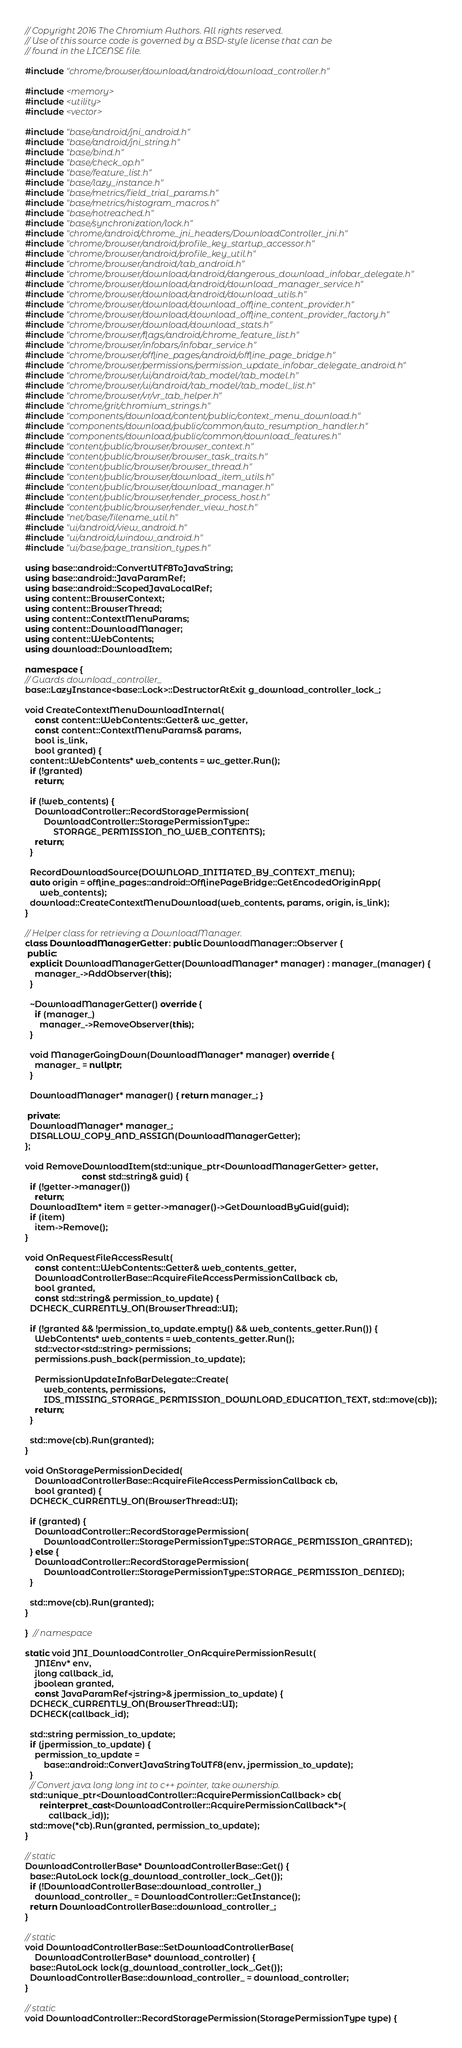<code> <loc_0><loc_0><loc_500><loc_500><_C++_>// Copyright 2016 The Chromium Authors. All rights reserved.
// Use of this source code is governed by a BSD-style license that can be
// found in the LICENSE file.

#include "chrome/browser/download/android/download_controller.h"

#include <memory>
#include <utility>
#include <vector>

#include "base/android/jni_android.h"
#include "base/android/jni_string.h"
#include "base/bind.h"
#include "base/check_op.h"
#include "base/feature_list.h"
#include "base/lazy_instance.h"
#include "base/metrics/field_trial_params.h"
#include "base/metrics/histogram_macros.h"
#include "base/notreached.h"
#include "base/synchronization/lock.h"
#include "chrome/android/chrome_jni_headers/DownloadController_jni.h"
#include "chrome/browser/android/profile_key_startup_accessor.h"
#include "chrome/browser/android/profile_key_util.h"
#include "chrome/browser/android/tab_android.h"
#include "chrome/browser/download/android/dangerous_download_infobar_delegate.h"
#include "chrome/browser/download/android/download_manager_service.h"
#include "chrome/browser/download/android/download_utils.h"
#include "chrome/browser/download/download_offline_content_provider.h"
#include "chrome/browser/download/download_offline_content_provider_factory.h"
#include "chrome/browser/download/download_stats.h"
#include "chrome/browser/flags/android/chrome_feature_list.h"
#include "chrome/browser/infobars/infobar_service.h"
#include "chrome/browser/offline_pages/android/offline_page_bridge.h"
#include "chrome/browser/permissions/permission_update_infobar_delegate_android.h"
#include "chrome/browser/ui/android/tab_model/tab_model.h"
#include "chrome/browser/ui/android/tab_model/tab_model_list.h"
#include "chrome/browser/vr/vr_tab_helper.h"
#include "chrome/grit/chromium_strings.h"
#include "components/download/content/public/context_menu_download.h"
#include "components/download/public/common/auto_resumption_handler.h"
#include "components/download/public/common/download_features.h"
#include "content/public/browser/browser_context.h"
#include "content/public/browser/browser_task_traits.h"
#include "content/public/browser/browser_thread.h"
#include "content/public/browser/download_item_utils.h"
#include "content/public/browser/download_manager.h"
#include "content/public/browser/render_process_host.h"
#include "content/public/browser/render_view_host.h"
#include "net/base/filename_util.h"
#include "ui/android/view_android.h"
#include "ui/android/window_android.h"
#include "ui/base/page_transition_types.h"

using base::android::ConvertUTF8ToJavaString;
using base::android::JavaParamRef;
using base::android::ScopedJavaLocalRef;
using content::BrowserContext;
using content::BrowserThread;
using content::ContextMenuParams;
using content::DownloadManager;
using content::WebContents;
using download::DownloadItem;

namespace {
// Guards download_controller_
base::LazyInstance<base::Lock>::DestructorAtExit g_download_controller_lock_;

void CreateContextMenuDownloadInternal(
    const content::WebContents::Getter& wc_getter,
    const content::ContextMenuParams& params,
    bool is_link,
    bool granted) {
  content::WebContents* web_contents = wc_getter.Run();
  if (!granted)
    return;

  if (!web_contents) {
    DownloadController::RecordStoragePermission(
        DownloadController::StoragePermissionType::
            STORAGE_PERMISSION_NO_WEB_CONTENTS);
    return;
  }

  RecordDownloadSource(DOWNLOAD_INITIATED_BY_CONTEXT_MENU);
  auto origin = offline_pages::android::OfflinePageBridge::GetEncodedOriginApp(
      web_contents);
  download::CreateContextMenuDownload(web_contents, params, origin, is_link);
}

// Helper class for retrieving a DownloadManager.
class DownloadManagerGetter : public DownloadManager::Observer {
 public:
  explicit DownloadManagerGetter(DownloadManager* manager) : manager_(manager) {
    manager_->AddObserver(this);
  }

  ~DownloadManagerGetter() override {
    if (manager_)
      manager_->RemoveObserver(this);
  }

  void ManagerGoingDown(DownloadManager* manager) override {
    manager_ = nullptr;
  }

  DownloadManager* manager() { return manager_; }

 private:
  DownloadManager* manager_;
  DISALLOW_COPY_AND_ASSIGN(DownloadManagerGetter);
};

void RemoveDownloadItem(std::unique_ptr<DownloadManagerGetter> getter,
                        const std::string& guid) {
  if (!getter->manager())
    return;
  DownloadItem* item = getter->manager()->GetDownloadByGuid(guid);
  if (item)
    item->Remove();
}

void OnRequestFileAccessResult(
    const content::WebContents::Getter& web_contents_getter,
    DownloadControllerBase::AcquireFileAccessPermissionCallback cb,
    bool granted,
    const std::string& permission_to_update) {
  DCHECK_CURRENTLY_ON(BrowserThread::UI);

  if (!granted && !permission_to_update.empty() && web_contents_getter.Run()) {
    WebContents* web_contents = web_contents_getter.Run();
    std::vector<std::string> permissions;
    permissions.push_back(permission_to_update);

    PermissionUpdateInfoBarDelegate::Create(
        web_contents, permissions,
        IDS_MISSING_STORAGE_PERMISSION_DOWNLOAD_EDUCATION_TEXT, std::move(cb));
    return;
  }

  std::move(cb).Run(granted);
}

void OnStoragePermissionDecided(
    DownloadControllerBase::AcquireFileAccessPermissionCallback cb,
    bool granted) {
  DCHECK_CURRENTLY_ON(BrowserThread::UI);

  if (granted) {
    DownloadController::RecordStoragePermission(
        DownloadController::StoragePermissionType::STORAGE_PERMISSION_GRANTED);
  } else {
    DownloadController::RecordStoragePermission(
        DownloadController::StoragePermissionType::STORAGE_PERMISSION_DENIED);
  }

  std::move(cb).Run(granted);
}

}  // namespace

static void JNI_DownloadController_OnAcquirePermissionResult(
    JNIEnv* env,
    jlong callback_id,
    jboolean granted,
    const JavaParamRef<jstring>& jpermission_to_update) {
  DCHECK_CURRENTLY_ON(BrowserThread::UI);
  DCHECK(callback_id);

  std::string permission_to_update;
  if (jpermission_to_update) {
    permission_to_update =
        base::android::ConvertJavaStringToUTF8(env, jpermission_to_update);
  }
  // Convert java long long int to c++ pointer, take ownership.
  std::unique_ptr<DownloadController::AcquirePermissionCallback> cb(
      reinterpret_cast<DownloadController::AcquirePermissionCallback*>(
          callback_id));
  std::move(*cb).Run(granted, permission_to_update);
}

// static
DownloadControllerBase* DownloadControllerBase::Get() {
  base::AutoLock lock(g_download_controller_lock_.Get());
  if (!DownloadControllerBase::download_controller_)
    download_controller_ = DownloadController::GetInstance();
  return DownloadControllerBase::download_controller_;
}

// static
void DownloadControllerBase::SetDownloadControllerBase(
    DownloadControllerBase* download_controller) {
  base::AutoLock lock(g_download_controller_lock_.Get());
  DownloadControllerBase::download_controller_ = download_controller;
}

// static
void DownloadController::RecordStoragePermission(StoragePermissionType type) {</code> 